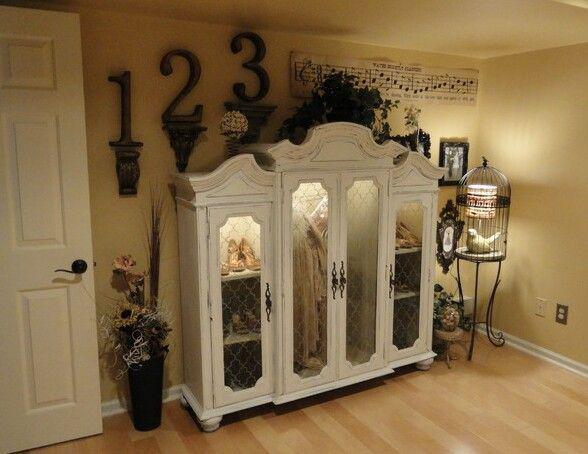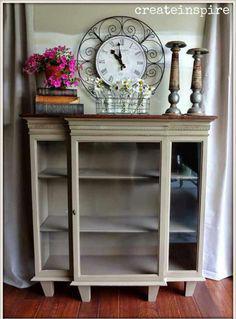The first image is the image on the left, the second image is the image on the right. For the images shown, is this caption "An image shows a flat-topped grayish cabinet with something round on the wall behind it and nothing inside it." true? Answer yes or no. Yes. The first image is the image on the left, the second image is the image on the right. Evaluate the accuracy of this statement regarding the images: "The cabinet on the left is visibly full of dishes, and the one on the right is not.". Is it true? Answer yes or no. No. The first image is the image on the left, the second image is the image on the right. For the images displayed, is the sentence "A low wooden cabinet in one image is made from the top of a larger hutch, sits on low rounded feet, and has four doors with long arched glass inserts." factually correct? Answer yes or no. Yes. 